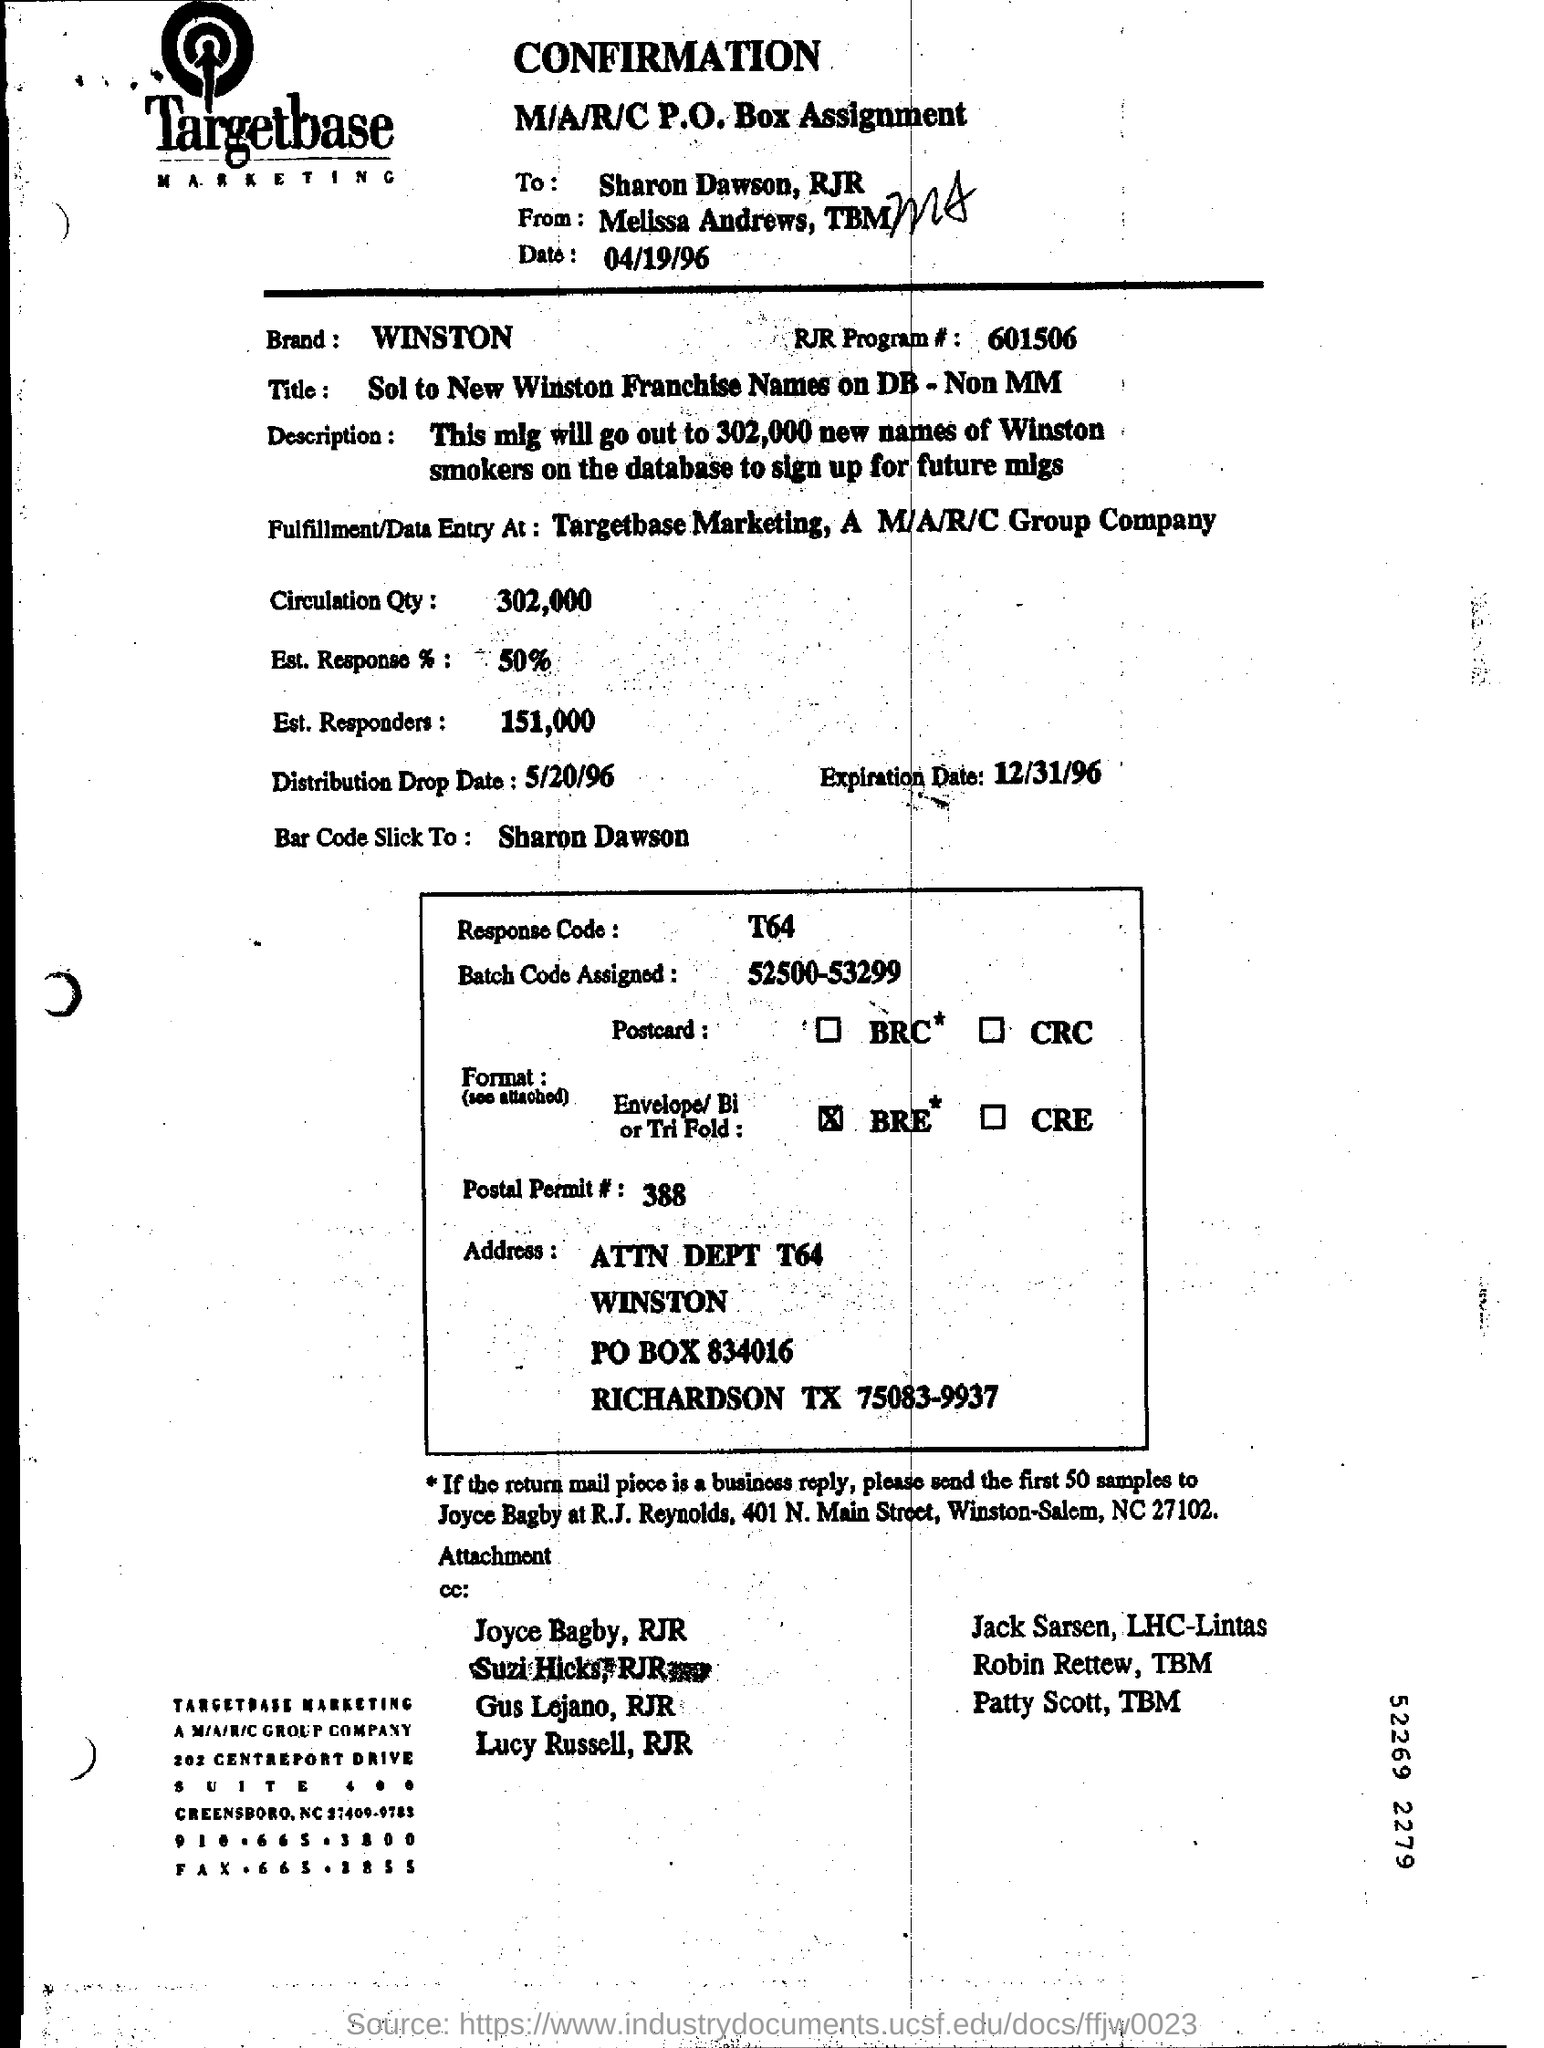What is the Est. Response %? The estimated response percentage listed on the document is 50%. This figure represents the expected rate at which individuals, out of the total circulation quantity, will engage with the campaign or offer addressed in the document. 